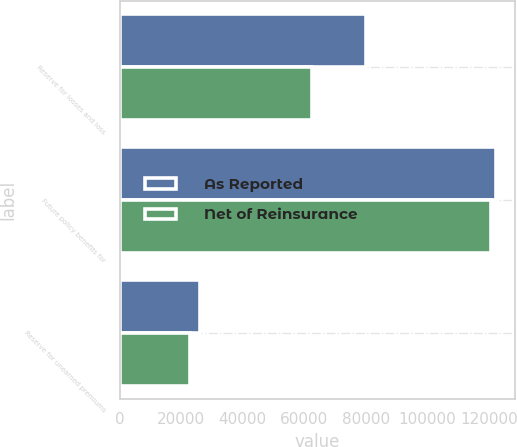<chart> <loc_0><loc_0><loc_500><loc_500><stacked_bar_chart><ecel><fcel>Reserve for losses and loss<fcel>Future policy benefits for<fcel>Reserve for unearned premiums<nl><fcel>As Reported<fcel>79999<fcel>122230<fcel>26271<nl><fcel>Net of Reinsurance<fcel>62630<fcel>120656<fcel>22759<nl></chart> 